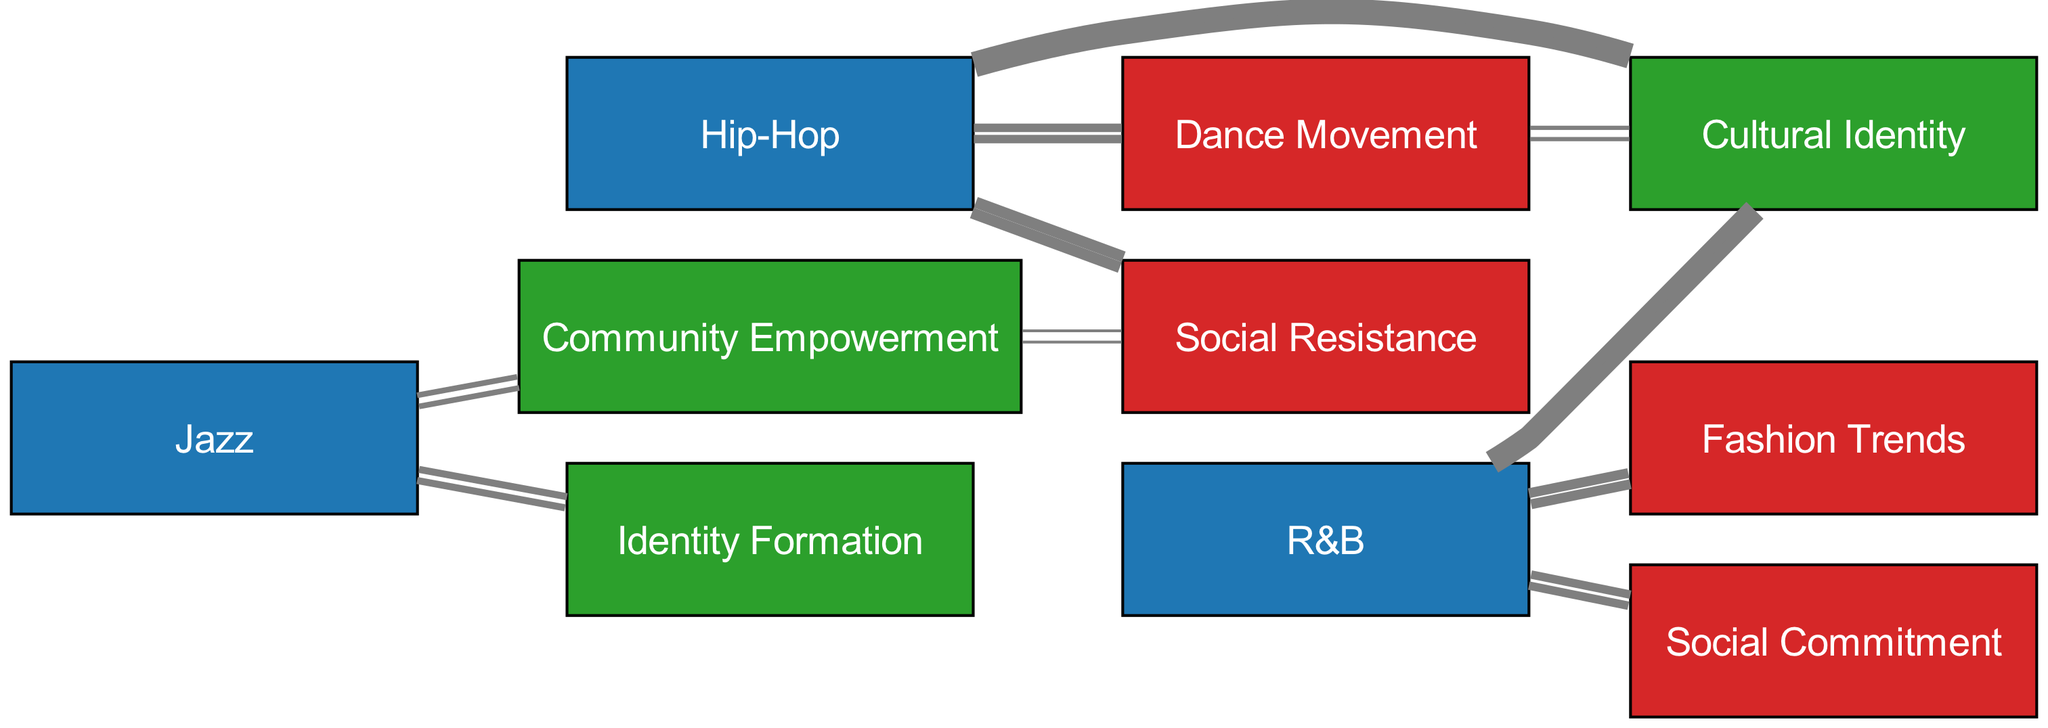What is the total number of nodes in the diagram? The diagram contains a total of 10 nodes that represent music genres, concepts, and behaviors.
Answer: 10 Which music genre has the highest value connection to Cultural Identity? Hip-Hop has a connection value of 10 to Cultural Identity, which is higher than any other music genre.
Answer: Hip-Hop How many connections lead to Fashion Trends? There is one direct connection from R&B to Fashion Trends with a value of 7.
Answer: 1 What is the value of the link from Jazz to Community Empowerment? The link from Jazz to Community Empowerment has a value of 4, indicating a notable influence.
Answer: 4 What connections does Hip-Hop have? Hip-Hop connects to Cultural Identity (10), Social Resistance (8), Dance Movement (6).
Answer: Cultural Identity, Social Resistance, Dance Movement Which two behaviors are influenced by R&B? R&B influences Fashion Trends (value 7) and Social Commitment (value 6).
Answer: Fashion Trends, Social Commitment How does Dance Movement contribute to Cultural Identity? Dance Movement has a direct connection to Cultural Identity with a value of 3, suggesting it plays a role in shaping identity.
Answer: 3 Which music genre has influenced Community Empowerment the least? Jazz has the least influence on Community Empowerment with a value of 4 compared to other genres.
Answer: Jazz What two connections indicate a relationship between Social Resistance and Cultural Identity? The connections indicating this relationship are from Hip-Hop (8) and Community Empowerment (2) to Social Resistance, which also influences Cultural Identity.
Answer: Hip-Hop, Community Empowerment Which behavior has no direct links to Cultural Identity? Social Commitment has no direct link to Cultural Identity, as its connections are only to R&B.
Answer: Social Commitment 